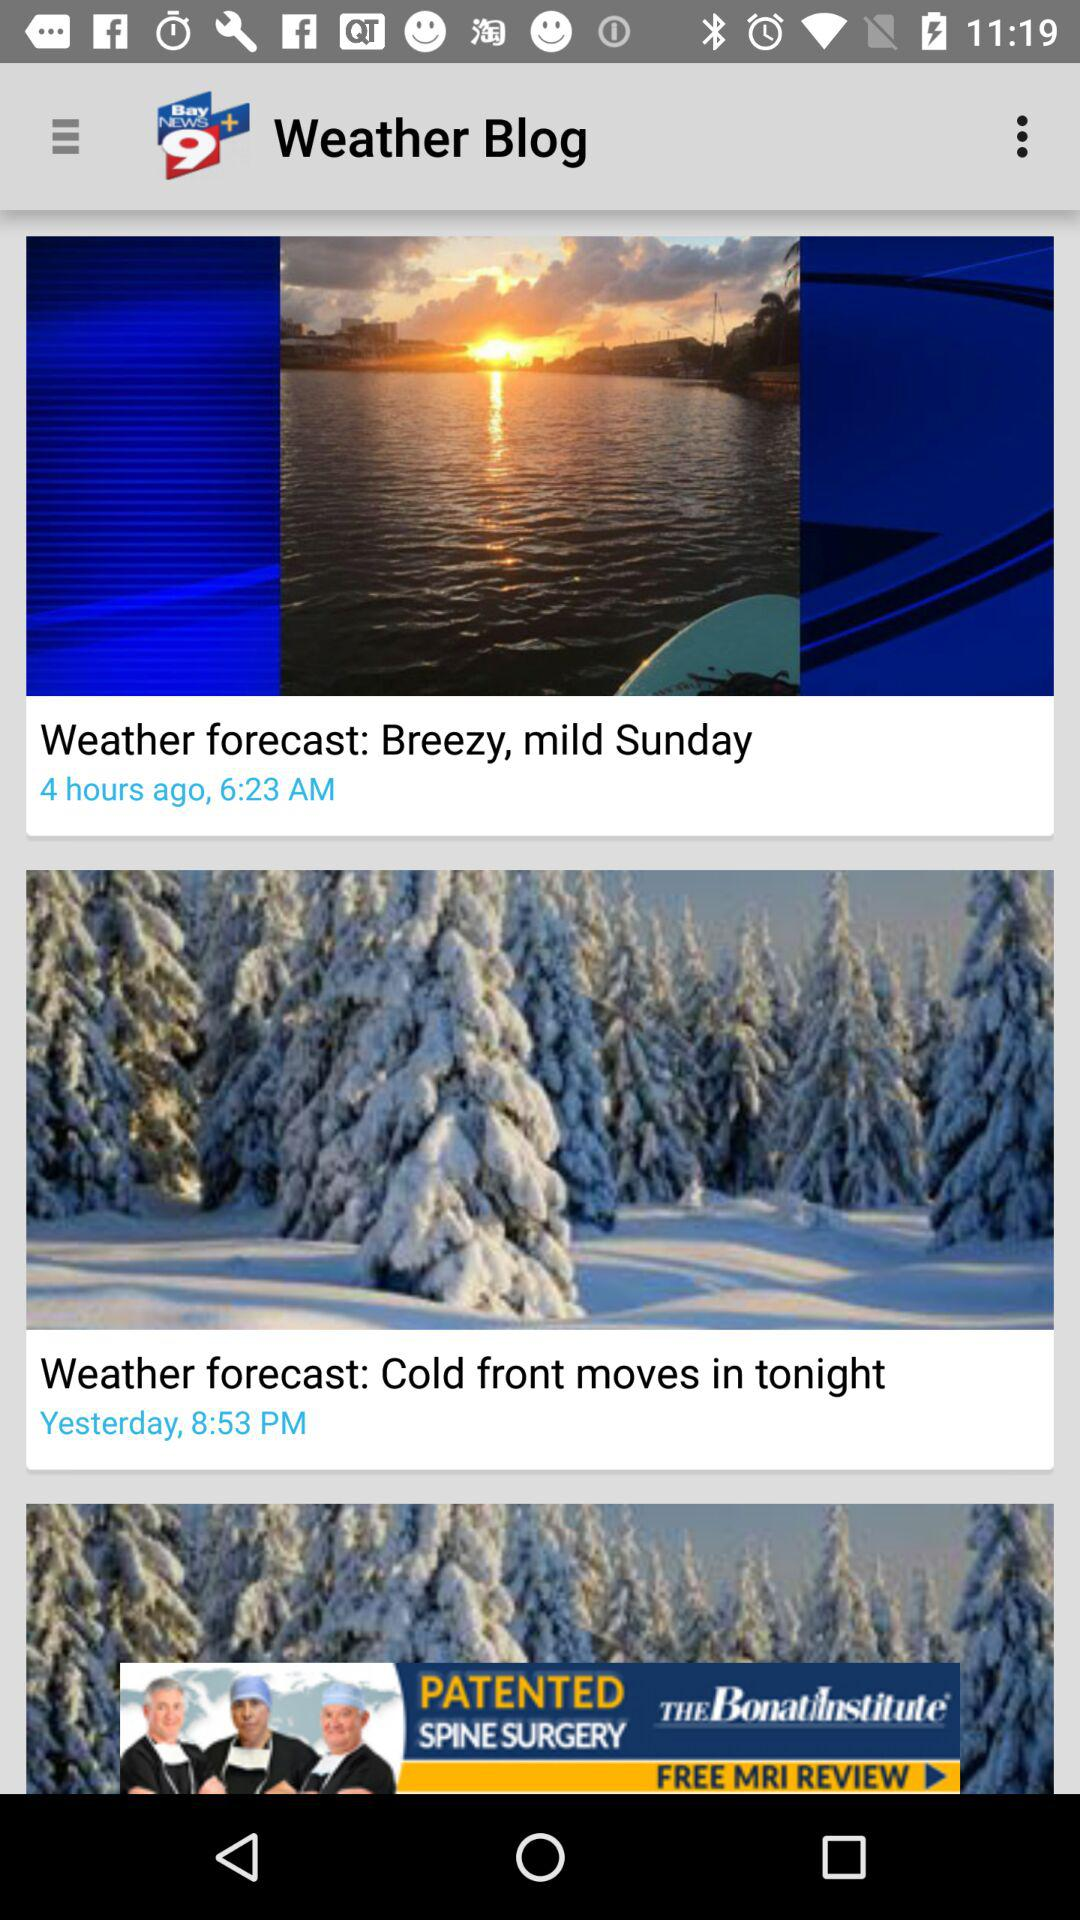Cold winds move in at what time?
When the provided information is insufficient, respond with <no answer>. <no answer> 